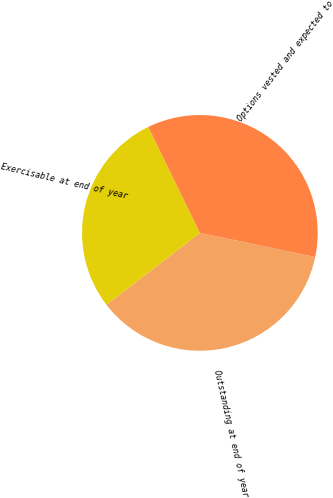Convert chart to OTSL. <chart><loc_0><loc_0><loc_500><loc_500><pie_chart><fcel>Outstanding at end of year<fcel>Exercisable at end of year<fcel>Options vested and expected to<nl><fcel>36.29%<fcel>28.21%<fcel>35.5%<nl></chart> 